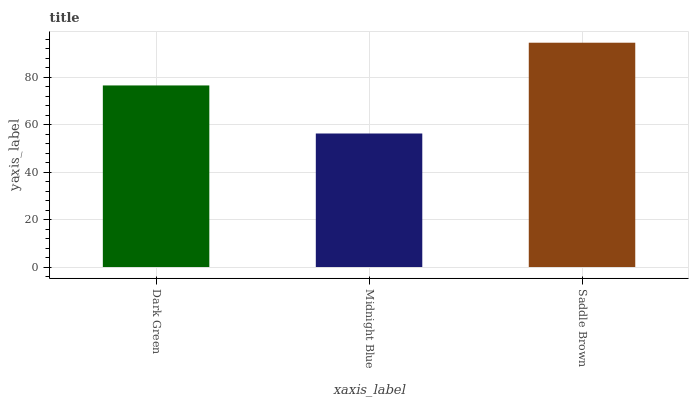Is Midnight Blue the minimum?
Answer yes or no. Yes. Is Saddle Brown the maximum?
Answer yes or no. Yes. Is Saddle Brown the minimum?
Answer yes or no. No. Is Midnight Blue the maximum?
Answer yes or no. No. Is Saddle Brown greater than Midnight Blue?
Answer yes or no. Yes. Is Midnight Blue less than Saddle Brown?
Answer yes or no. Yes. Is Midnight Blue greater than Saddle Brown?
Answer yes or no. No. Is Saddle Brown less than Midnight Blue?
Answer yes or no. No. Is Dark Green the high median?
Answer yes or no. Yes. Is Dark Green the low median?
Answer yes or no. Yes. Is Midnight Blue the high median?
Answer yes or no. No. Is Saddle Brown the low median?
Answer yes or no. No. 